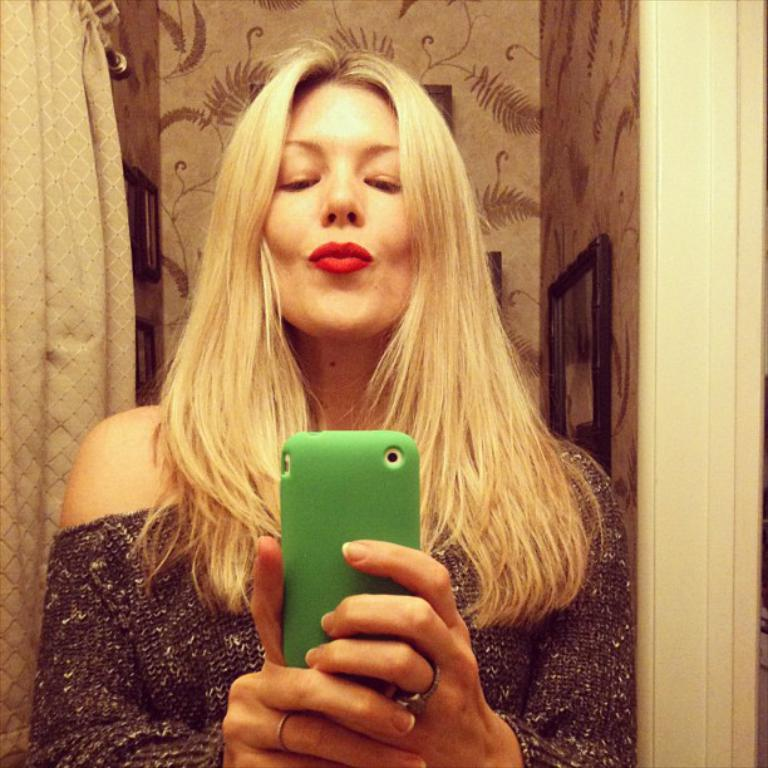Who is present in the image? There is a woman in the image. What is the woman doing in the image? The woman is standing in the image. What object is the woman holding in her hand? The woman is holding a mobile phone in her hand. What can be seen in the background of the image? There are curtains and a wall in the background of the image. What type of argument is taking place between the woman and the tiger in the image? There is no tiger present in the image, and therefore no argument can be observed. 